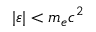Convert formula to latex. <formula><loc_0><loc_0><loc_500><loc_500>| \varepsilon | < m _ { e } c ^ { 2 }</formula> 